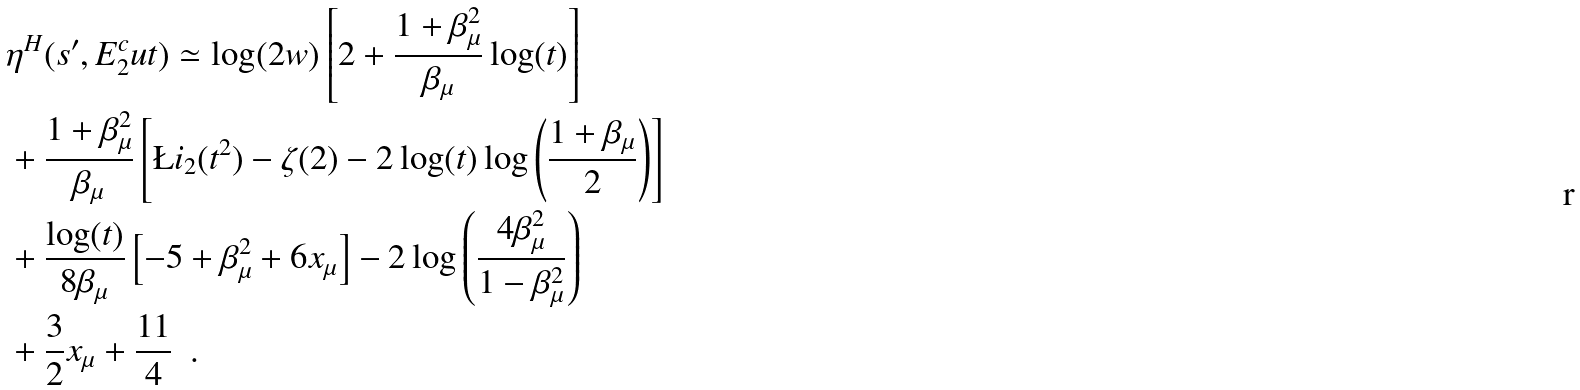Convert formula to latex. <formula><loc_0><loc_0><loc_500><loc_500>& \eta ^ { H } ( s ^ { \prime } , E _ { 2 } ^ { c } u t ) \simeq \log ( 2 w ) \left [ 2 + \frac { 1 + \beta _ { \mu } ^ { 2 } } { \beta _ { \mu } } \log ( t ) \right ] \\ & + \frac { 1 + \beta _ { \mu } ^ { 2 } } { \beta _ { \mu } } \left [ \L i _ { 2 } ( t ^ { 2 } ) - \zeta ( 2 ) - 2 \log ( t ) \log \left ( \frac { 1 + \beta _ { \mu } } { 2 } \right ) \right ] \\ & + \frac { \log ( t ) } { 8 \beta _ { \mu } } \left [ - 5 + \beta _ { \mu } ^ { 2 } + 6 x _ { \mu } \right ] - 2 \log \left ( \frac { 4 \beta _ { \mu } ^ { 2 } } { 1 - \beta _ { \mu } ^ { 2 } } \right ) \\ & + \frac { 3 } { 2 } x _ { \mu } + \frac { 1 1 } { 4 } \ \ .</formula> 